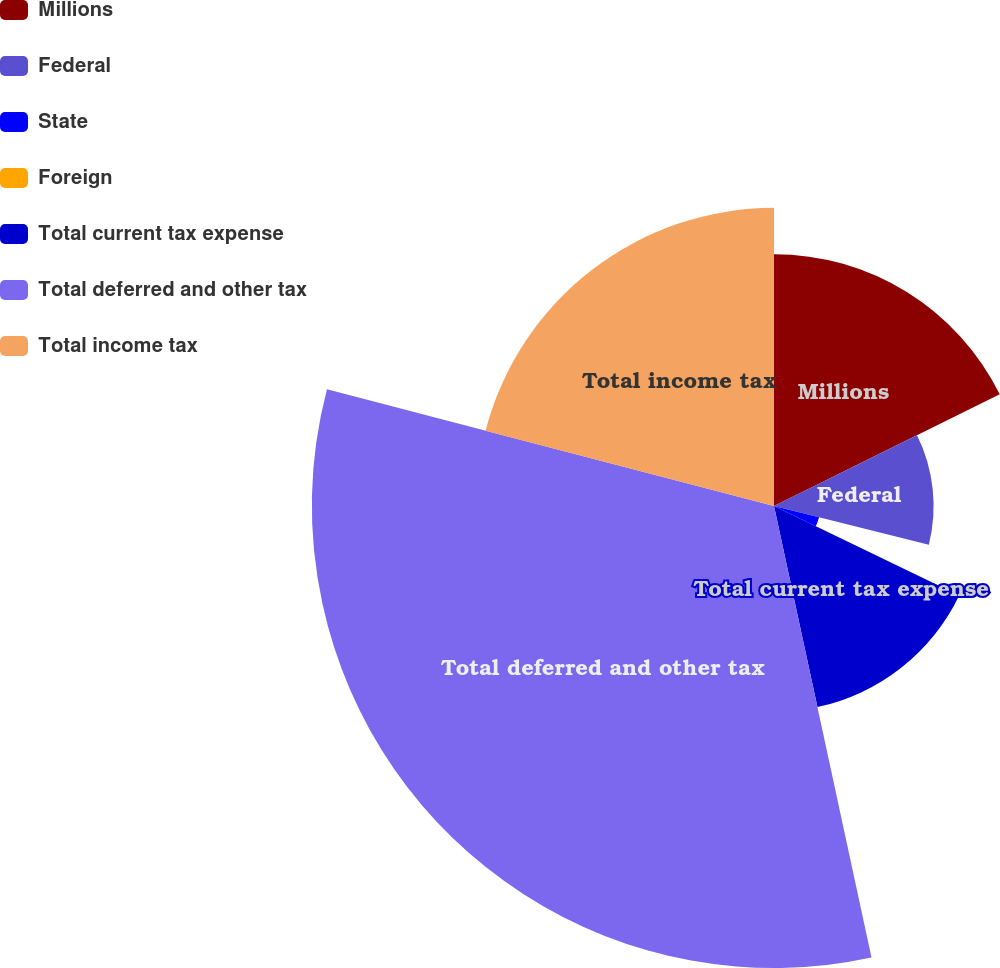Convert chart to OTSL. <chart><loc_0><loc_0><loc_500><loc_500><pie_chart><fcel>Millions<fcel>Federal<fcel>State<fcel>Foreign<fcel>Total current tax expense<fcel>Total deferred and other tax<fcel>Total income tax<nl><fcel>17.69%<fcel>11.21%<fcel>3.26%<fcel>0.01%<fcel>14.45%<fcel>32.45%<fcel>20.94%<nl></chart> 